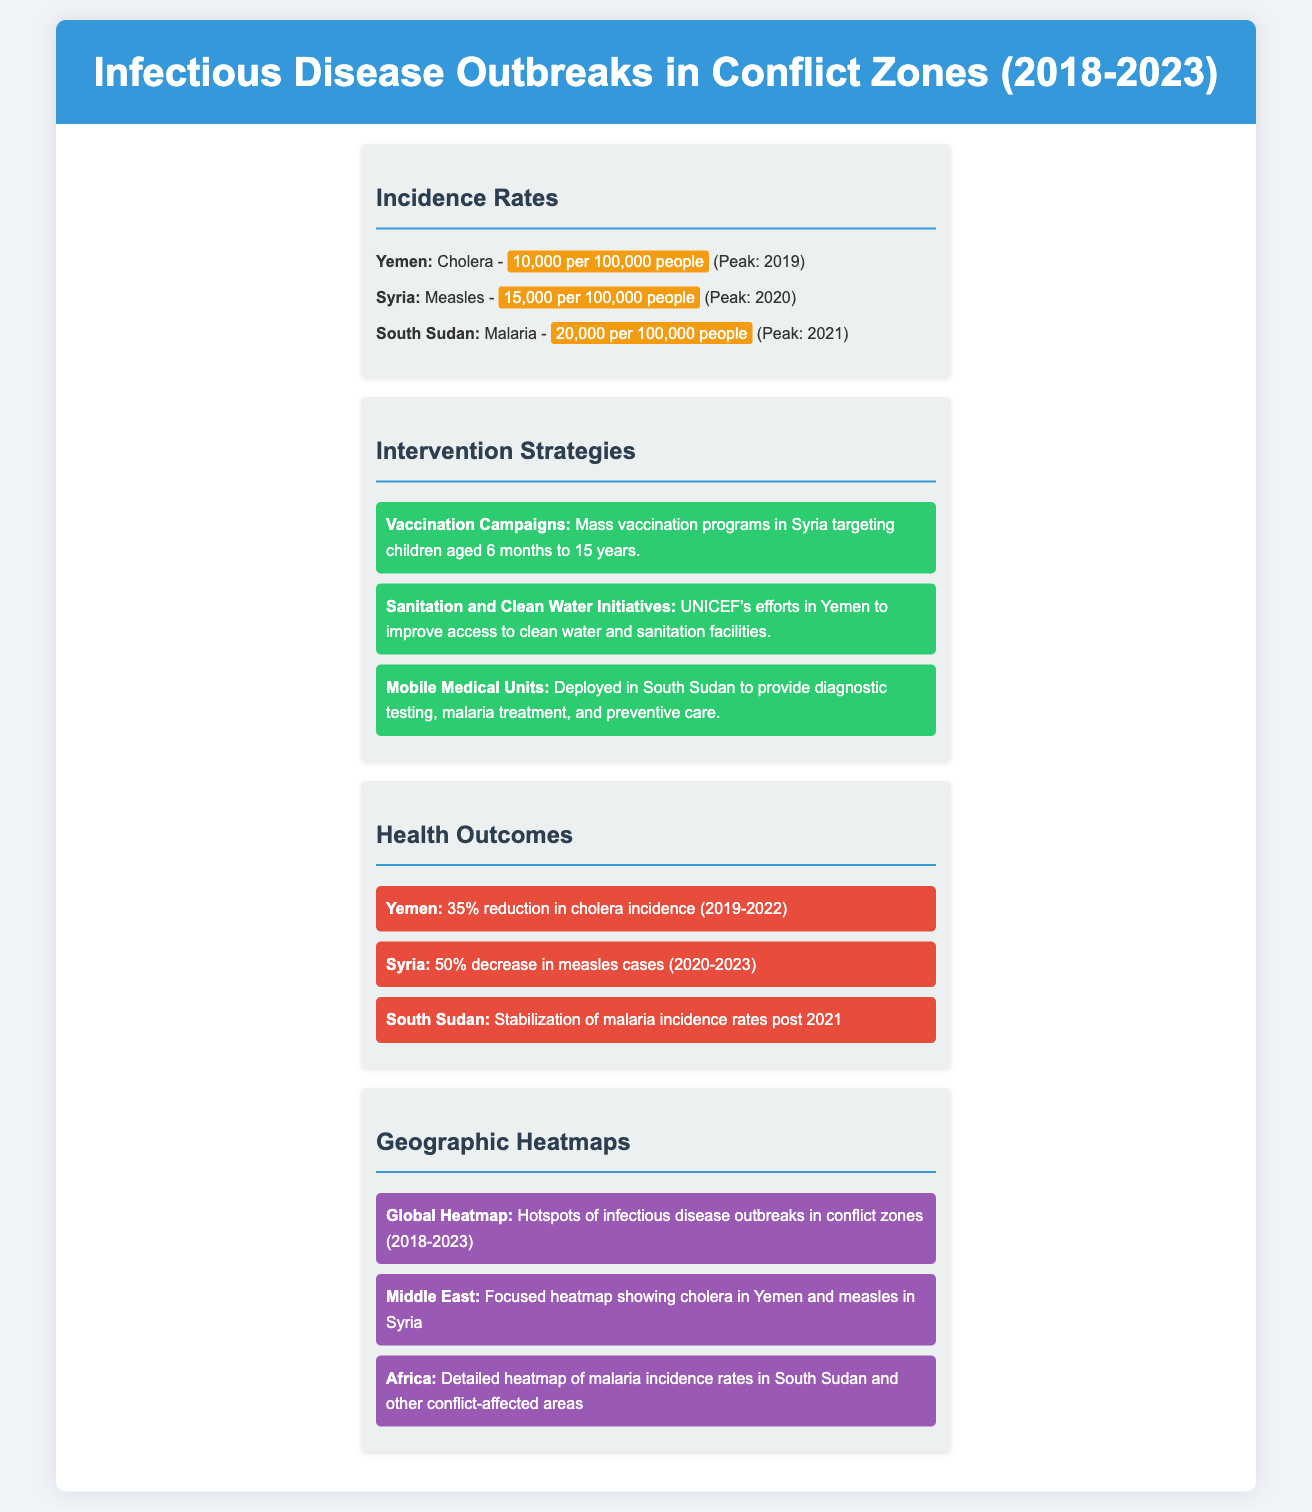what was the peak incidence rate of cholera in Yemen? The peak incidence rate of cholera in Yemen was 10,000 per 100,000 people in 2019.
Answer: 10,000 per 100,000 people what intervention strategy was implemented in Syria? The intervention strategy in Syria was mass vaccination programs targeting children aged 6 months to 15 years.
Answer: Mass vaccination programs how much did the cholera incidence reduce in Yemen from 2019 to 2022? The cholera incidence in Yemen saw a 35% reduction from 2019 to 2022.
Answer: 35% what was the peak incidence of malaria in South Sudan? The peak incidence rate of malaria in South Sudan was 20,000 per 100,000 people in 2021.
Answer: 20,000 per 100,000 people what significant health outcome occurred in Syria from 2020 to 2023? There was a 50% decrease in measles cases in Syria from 2020 to 2023.
Answer: 50% decrease which organization focused on sanitation in Yemen? UNICEF was the organization focused on sanitation and clean water initiatives in Yemen.
Answer: UNICEF which geographic area had details on malaria incidence rates? The geographic area that had details on malaria incidence rates was Africa.
Answer: Africa what was highlighted about infectious disease outbreaks from 2018 to 2023? The global heatmap highlighted hotspots of infectious disease outbreaks in conflict zones from 2018 to 2023.
Answer: Hotspots of infectious disease outbreaks 